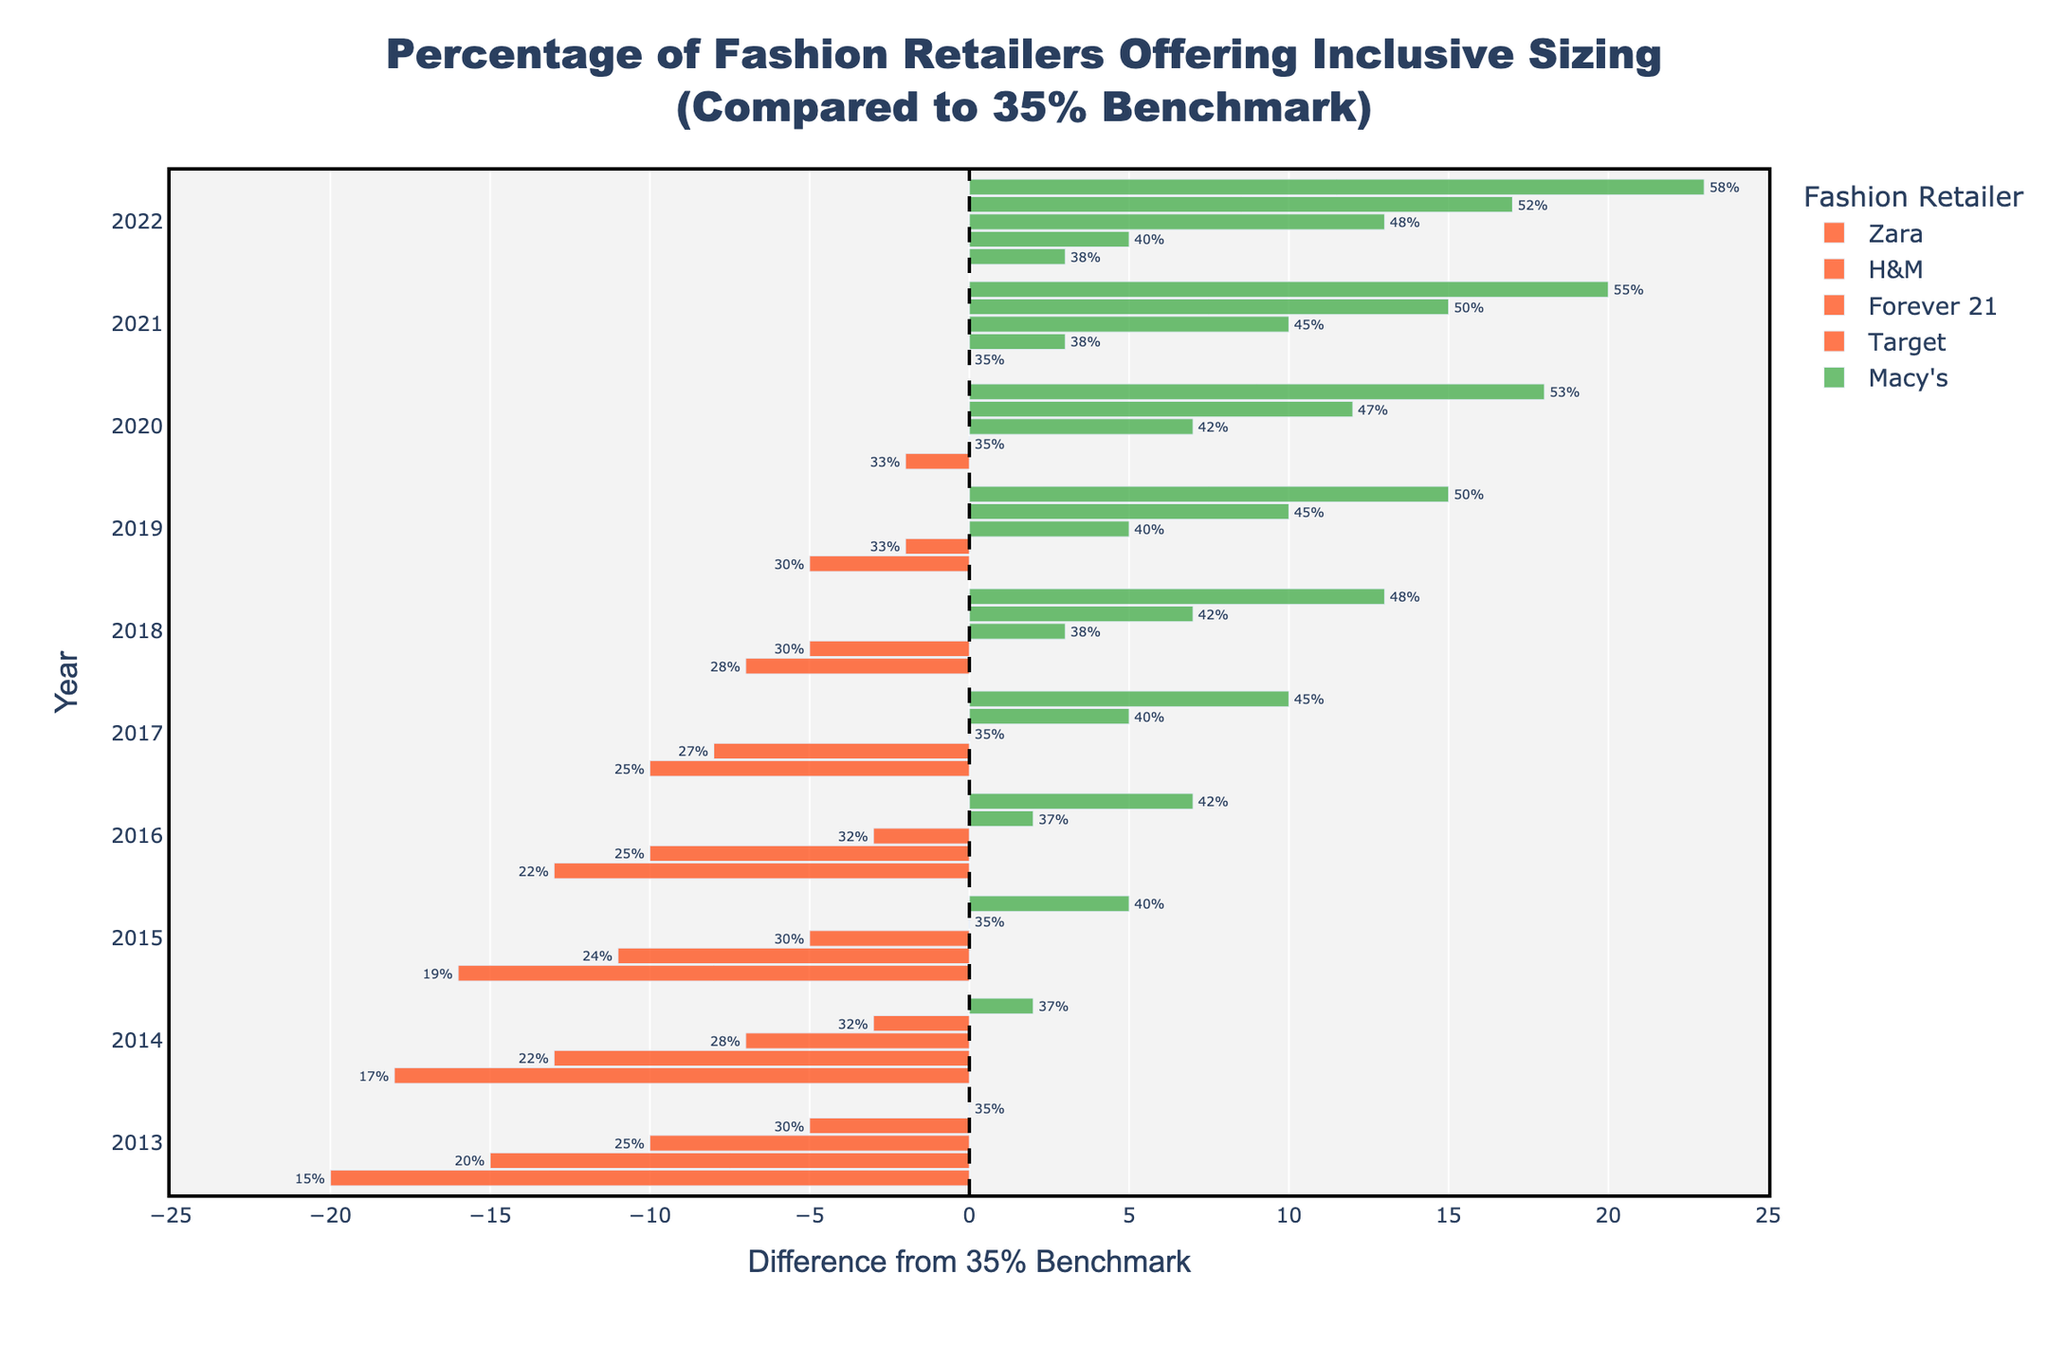What trend do you observe for the inclusive sizing percentage offered by Zara from 2013 to 2022? The inclusive sizing percentage offered by Zara has increased steadily from 15% in 2013 to 38% in 2022.
Answer: Increasing trend Which retailer had the highest percentage change in offering inclusive sizing compared to the 35% benchmark in 2022? By looking at the bars for 2022, Macy's had the highest positive difference of 23% compared to the 35% benchmark (58% actual - 35% benchmark).
Answer: Macy's Which year did Forever 21 first exceed the 35% benchmark for inclusive sizing? Forever 21 first exceeded the 35% benchmark in 2017 with a percentage of 35%.
Answer: 2017 Compare the inclusive sizing percentages of H&M and Target in 2015. Which retailer had a higher percentage, and by how much? In 2015, H&M had 24% and Target had 35%. Target had a higher percentage by 11% (35% - 24%).
Answer: Target by 11% Which retailer showed the smallest difference from the 35% benchmark in 2016? In 2016, H&M had a percentage of 25%, resulting in a difference of -10% from the benchmark (25% - 35%), which is the smallest difference.
Answer: H&M In which year did Macy's first offer 50% or more inclusive sizing? Macy’s reached or exceeded 50% for the first time in 2019.
Answer: 2019 What was the difference from the 35% benchmark for Target's inclusive sizing in 2020? Target's percentage in 2020 was 47%, and the difference from the benchmark is 12% (47% - 35%).
Answer: 12% Identify the years where Zara was below the 35% benchmark and state the differences. Zara was below the benchmark from 2013 to 2018. The differences were: -20% (2013), -18% (2014), -16% (2015), -13% (2016), -10% (2017), -7% (2018).
Answer: 2013 to 2018 with differences: -20%, -18%, -16%, -13%, -10%, -7% Did any retailer hit exactly the 35% benchmark in any year? If so, which retailer(s) and year(s)? Forever 21 hit exactly the 35% benchmark in 2017.
Answer: Forever 21 in 2017 How many retailers offered more than a 5% increase in inclusive sizing between 2020 and 2022? Zara (33% to 38%, +5%), H&M (35% to 40%, +5%), Forever 21 (42% to 48%, +6%), Target (47% to 52%, +5%), Macy's (53% to 58%, +5%) all showed more than a 5% increase.
Answer: 5 retailers 